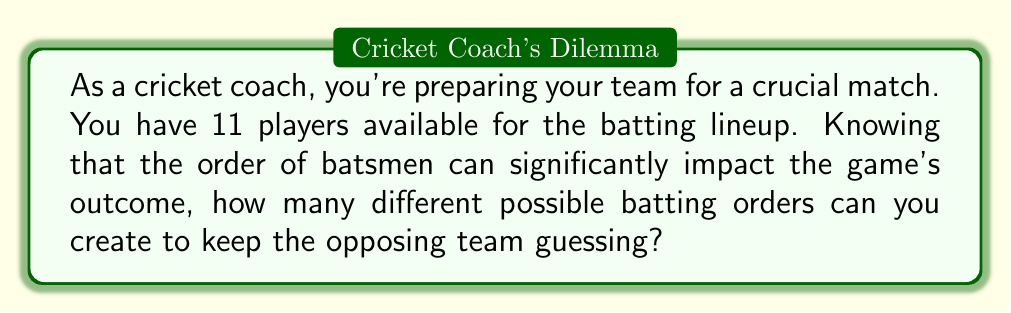What is the answer to this math problem? Let's approach this step-by-step:

1) In cricket, a full team consists of 11 players, all of whom will bat in a specific order.

2) This scenario is a perfect example of a permutation problem. We need to arrange 11 players in 11 positions, where the order matters.

3) The formula for permutations of n distinct objects is:

   $$P(n) = n!$$

   Where $n!$ represents the factorial of $n$.

4) In this case, $n = 11$, so we need to calculate $11!$

5) Let's expand this:

   $$11! = 11 \times 10 \times 9 \times 8 \times 7 \times 6 \times 5 \times 4 \times 3 \times 2 \times 1$$

6) Calculating this out:

   $$11! = 39,916,800$$

Therefore, there are 39,916,800 different possible batting orders for a cricket team of 11 players.

This vast number of possibilities highlights the importance of strategic thinking in selecting the batting order, as it can significantly influence the game's outcome.
Answer: $39,916,800$ 